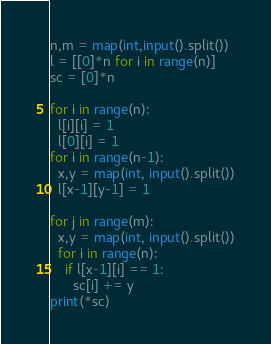<code> <loc_0><loc_0><loc_500><loc_500><_Python_>n,m = map(int,input().split())
l = [[0]*n for i in range(n)]
sc = [0]*n

for i in range(n):
  l[i][i] = 1
  l[0][i] = 1
for i in range(n-1):
  x,y = map(int, input().split())
  l[x-1][y-1] = 1
  
for j in range(m):
  x,y = map(int, input().split())
  for i in range(n):
    if l[x-1][i] == 1:
      sc[i] += y
print(*sc)</code> 